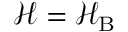Convert formula to latex. <formula><loc_0><loc_0><loc_500><loc_500>\mathcal { H } = \mathcal { H } _ { B }</formula> 